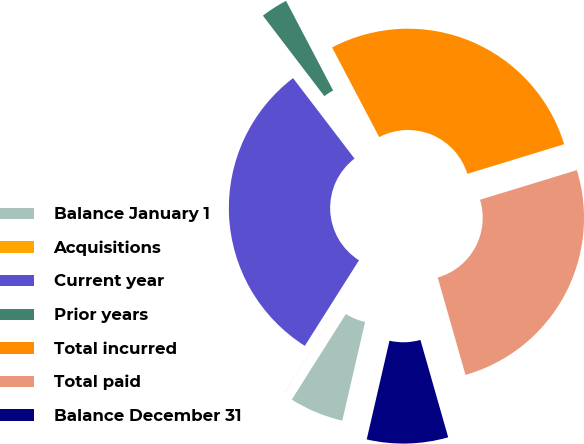Convert chart. <chart><loc_0><loc_0><loc_500><loc_500><pie_chart><fcel>Balance January 1<fcel>Acquisitions<fcel>Current year<fcel>Prior years<fcel>Total incurred<fcel>Total paid<fcel>Balance December 31<nl><fcel>5.36%<fcel>0.01%<fcel>30.64%<fcel>2.68%<fcel>27.97%<fcel>25.3%<fcel>8.03%<nl></chart> 